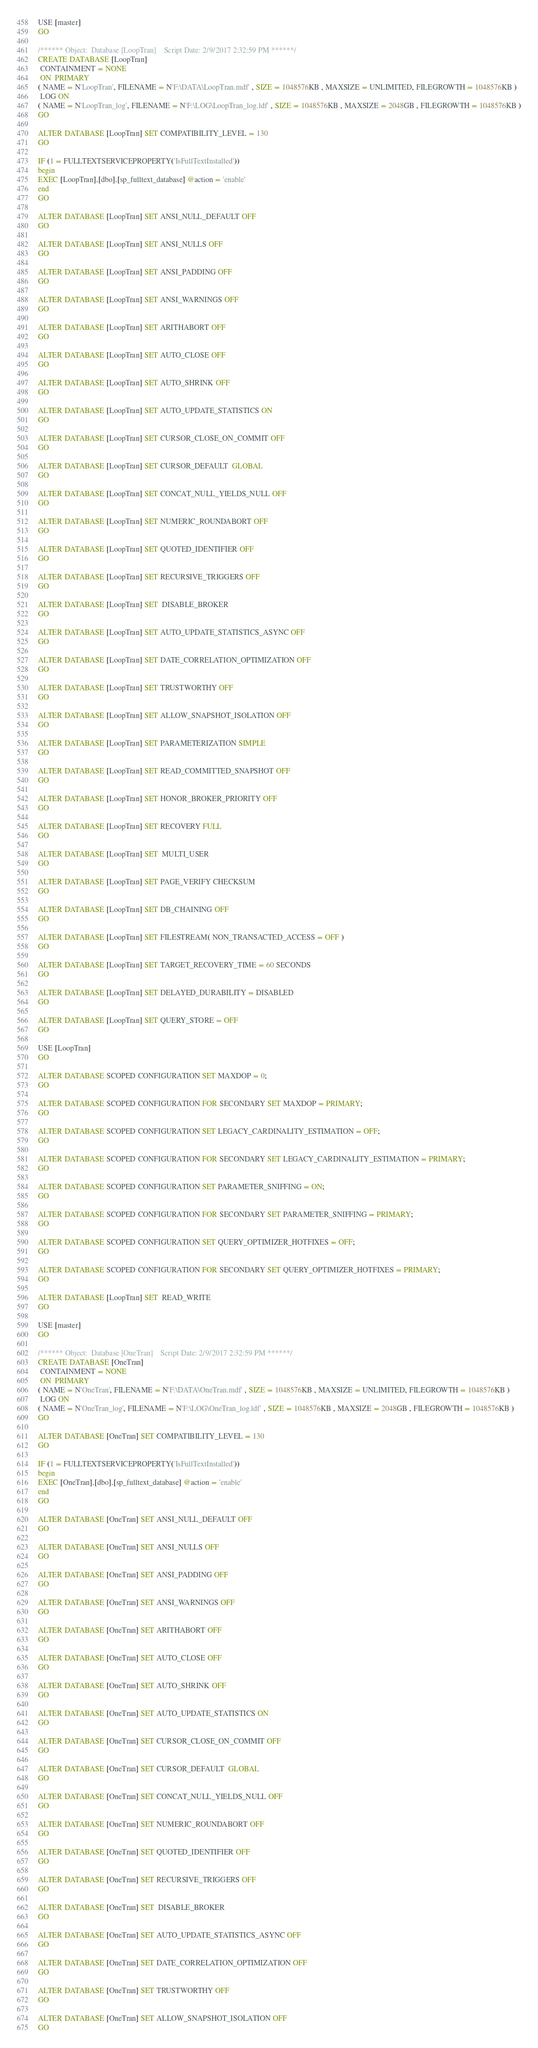Convert code to text. <code><loc_0><loc_0><loc_500><loc_500><_SQL_>USE [master]
GO

/****** Object:  Database [LoopTran]    Script Date: 2/9/2017 2:32:59 PM ******/
CREATE DATABASE [LoopTran]
 CONTAINMENT = NONE
 ON  PRIMARY 
( NAME = N'LoopTran', FILENAME = N'F:\DATA\LoopTran.mdf' , SIZE = 1048576KB , MAXSIZE = UNLIMITED, FILEGROWTH = 1048576KB )
 LOG ON 
( NAME = N'LoopTran_log', FILENAME = N'F:\LOG\LoopTran_log.ldf' , SIZE = 1048576KB , MAXSIZE = 2048GB , FILEGROWTH = 1048576KB )
GO

ALTER DATABASE [LoopTran] SET COMPATIBILITY_LEVEL = 130
GO

IF (1 = FULLTEXTSERVICEPROPERTY('IsFullTextInstalled'))
begin
EXEC [LoopTran].[dbo].[sp_fulltext_database] @action = 'enable'
end
GO

ALTER DATABASE [LoopTran] SET ANSI_NULL_DEFAULT OFF 
GO

ALTER DATABASE [LoopTran] SET ANSI_NULLS OFF 
GO

ALTER DATABASE [LoopTran] SET ANSI_PADDING OFF 
GO

ALTER DATABASE [LoopTran] SET ANSI_WARNINGS OFF 
GO

ALTER DATABASE [LoopTran] SET ARITHABORT OFF 
GO

ALTER DATABASE [LoopTran] SET AUTO_CLOSE OFF 
GO

ALTER DATABASE [LoopTran] SET AUTO_SHRINK OFF 
GO

ALTER DATABASE [LoopTran] SET AUTO_UPDATE_STATISTICS ON 
GO

ALTER DATABASE [LoopTran] SET CURSOR_CLOSE_ON_COMMIT OFF 
GO

ALTER DATABASE [LoopTran] SET CURSOR_DEFAULT  GLOBAL 
GO

ALTER DATABASE [LoopTran] SET CONCAT_NULL_YIELDS_NULL OFF 
GO

ALTER DATABASE [LoopTran] SET NUMERIC_ROUNDABORT OFF 
GO

ALTER DATABASE [LoopTran] SET QUOTED_IDENTIFIER OFF 
GO

ALTER DATABASE [LoopTran] SET RECURSIVE_TRIGGERS OFF 
GO

ALTER DATABASE [LoopTran] SET  DISABLE_BROKER 
GO

ALTER DATABASE [LoopTran] SET AUTO_UPDATE_STATISTICS_ASYNC OFF 
GO

ALTER DATABASE [LoopTran] SET DATE_CORRELATION_OPTIMIZATION OFF 
GO

ALTER DATABASE [LoopTran] SET TRUSTWORTHY OFF 
GO

ALTER DATABASE [LoopTran] SET ALLOW_SNAPSHOT_ISOLATION OFF 
GO

ALTER DATABASE [LoopTran] SET PARAMETERIZATION SIMPLE 
GO

ALTER DATABASE [LoopTran] SET READ_COMMITTED_SNAPSHOT OFF 
GO

ALTER DATABASE [LoopTran] SET HONOR_BROKER_PRIORITY OFF 
GO

ALTER DATABASE [LoopTran] SET RECOVERY FULL 
GO

ALTER DATABASE [LoopTran] SET  MULTI_USER 
GO

ALTER DATABASE [LoopTran] SET PAGE_VERIFY CHECKSUM  
GO

ALTER DATABASE [LoopTran] SET DB_CHAINING OFF 
GO

ALTER DATABASE [LoopTran] SET FILESTREAM( NON_TRANSACTED_ACCESS = OFF ) 
GO

ALTER DATABASE [LoopTran] SET TARGET_RECOVERY_TIME = 60 SECONDS 
GO

ALTER DATABASE [LoopTran] SET DELAYED_DURABILITY = DISABLED 
GO

ALTER DATABASE [LoopTran] SET QUERY_STORE = OFF
GO

USE [LoopTran]
GO

ALTER DATABASE SCOPED CONFIGURATION SET MAXDOP = 0;
GO

ALTER DATABASE SCOPED CONFIGURATION FOR SECONDARY SET MAXDOP = PRIMARY;
GO

ALTER DATABASE SCOPED CONFIGURATION SET LEGACY_CARDINALITY_ESTIMATION = OFF;
GO

ALTER DATABASE SCOPED CONFIGURATION FOR SECONDARY SET LEGACY_CARDINALITY_ESTIMATION = PRIMARY;
GO

ALTER DATABASE SCOPED CONFIGURATION SET PARAMETER_SNIFFING = ON;
GO

ALTER DATABASE SCOPED CONFIGURATION FOR SECONDARY SET PARAMETER_SNIFFING = PRIMARY;
GO

ALTER DATABASE SCOPED CONFIGURATION SET QUERY_OPTIMIZER_HOTFIXES = OFF;
GO

ALTER DATABASE SCOPED CONFIGURATION FOR SECONDARY SET QUERY_OPTIMIZER_HOTFIXES = PRIMARY;
GO

ALTER DATABASE [LoopTran] SET  READ_WRITE 
GO

USE [master]
GO

/****** Object:  Database [OneTran]    Script Date: 2/9/2017 2:32:59 PM ******/
CREATE DATABASE [OneTran]
 CONTAINMENT = NONE
 ON  PRIMARY 
( NAME = N'OneTran', FILENAME = N'F:\DATA\OneTran.mdf' , SIZE = 1048576KB , MAXSIZE = UNLIMITED, FILEGROWTH = 1048576KB )
 LOG ON 
( NAME = N'OneTran_log', FILENAME = N'F:\LOG\OneTran_log.ldf' , SIZE = 1048576KB , MAXSIZE = 2048GB , FILEGROWTH = 1048576KB )
GO

ALTER DATABASE [OneTran] SET COMPATIBILITY_LEVEL = 130
GO

IF (1 = FULLTEXTSERVICEPROPERTY('IsFullTextInstalled'))
begin
EXEC [OneTran].[dbo].[sp_fulltext_database] @action = 'enable'
end
GO

ALTER DATABASE [OneTran] SET ANSI_NULL_DEFAULT OFF 
GO

ALTER DATABASE [OneTran] SET ANSI_NULLS OFF 
GO

ALTER DATABASE [OneTran] SET ANSI_PADDING OFF 
GO

ALTER DATABASE [OneTran] SET ANSI_WARNINGS OFF 
GO

ALTER DATABASE [OneTran] SET ARITHABORT OFF 
GO

ALTER DATABASE [OneTran] SET AUTO_CLOSE OFF 
GO

ALTER DATABASE [OneTran] SET AUTO_SHRINK OFF 
GO

ALTER DATABASE [OneTran] SET AUTO_UPDATE_STATISTICS ON 
GO

ALTER DATABASE [OneTran] SET CURSOR_CLOSE_ON_COMMIT OFF 
GO

ALTER DATABASE [OneTran] SET CURSOR_DEFAULT  GLOBAL 
GO

ALTER DATABASE [OneTran] SET CONCAT_NULL_YIELDS_NULL OFF 
GO

ALTER DATABASE [OneTran] SET NUMERIC_ROUNDABORT OFF 
GO

ALTER DATABASE [OneTran] SET QUOTED_IDENTIFIER OFF 
GO

ALTER DATABASE [OneTran] SET RECURSIVE_TRIGGERS OFF 
GO

ALTER DATABASE [OneTran] SET  DISABLE_BROKER 
GO

ALTER DATABASE [OneTran] SET AUTO_UPDATE_STATISTICS_ASYNC OFF 
GO

ALTER DATABASE [OneTran] SET DATE_CORRELATION_OPTIMIZATION OFF 
GO

ALTER DATABASE [OneTran] SET TRUSTWORTHY OFF 
GO

ALTER DATABASE [OneTran] SET ALLOW_SNAPSHOT_ISOLATION OFF 
GO
</code> 